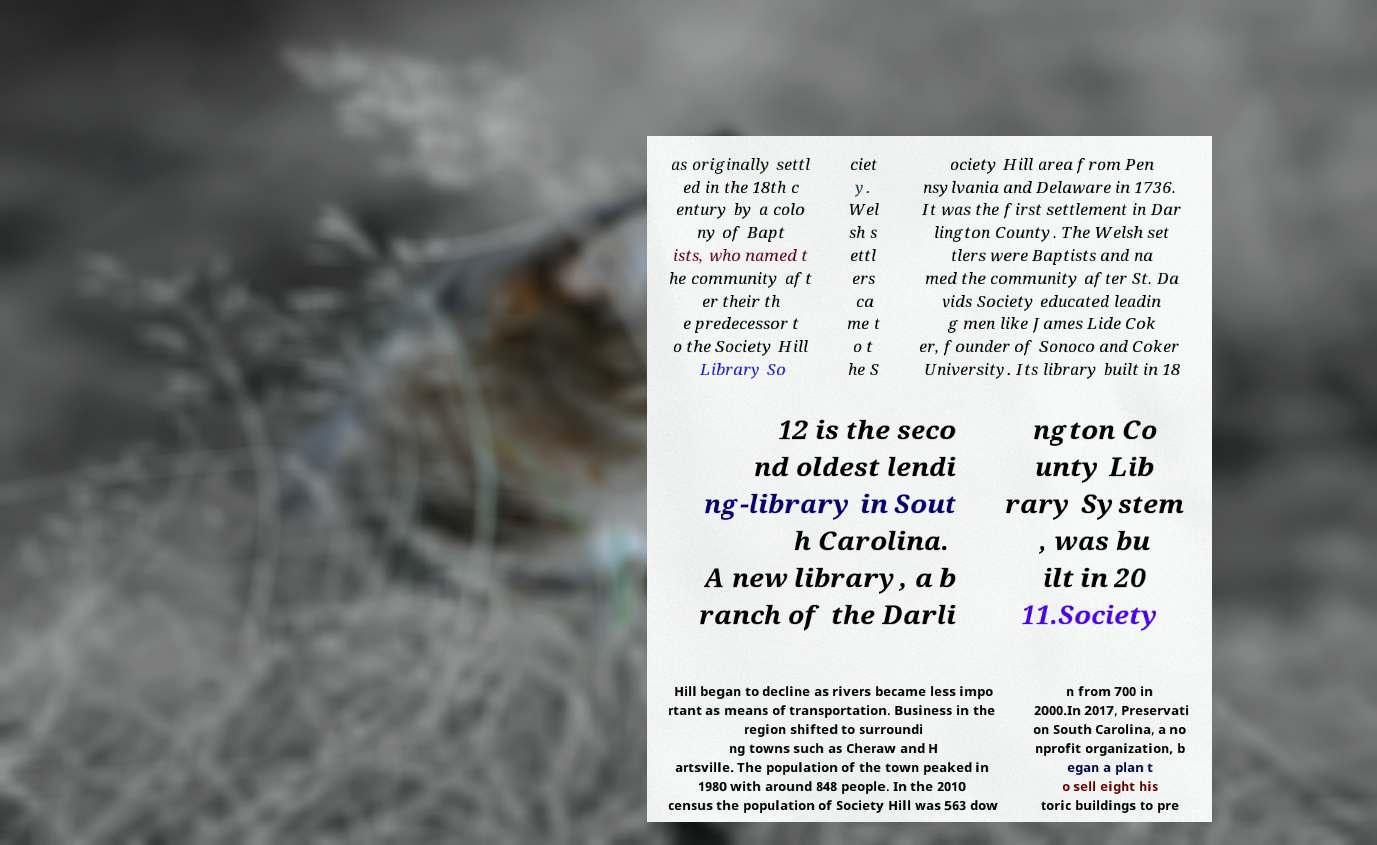Could you extract and type out the text from this image? as originally settl ed in the 18th c entury by a colo ny of Bapt ists, who named t he community aft er their th e predecessor t o the Society Hill Library So ciet y. Wel sh s ettl ers ca me t o t he S ociety Hill area from Pen nsylvania and Delaware in 1736. It was the first settlement in Dar lington County. The Welsh set tlers were Baptists and na med the community after St. Da vids Society educated leadin g men like James Lide Cok er, founder of Sonoco and Coker University. Its library built in 18 12 is the seco nd oldest lendi ng-library in Sout h Carolina. A new library, a b ranch of the Darli ngton Co unty Lib rary System , was bu ilt in 20 11.Society Hill began to decline as rivers became less impo rtant as means of transportation. Business in the region shifted to surroundi ng towns such as Cheraw and H artsville. The population of the town peaked in 1980 with around 848 people. In the 2010 census the population of Society Hill was 563 dow n from 700 in 2000.In 2017, Preservati on South Carolina, a no nprofit organization, b egan a plan t o sell eight his toric buildings to pre 